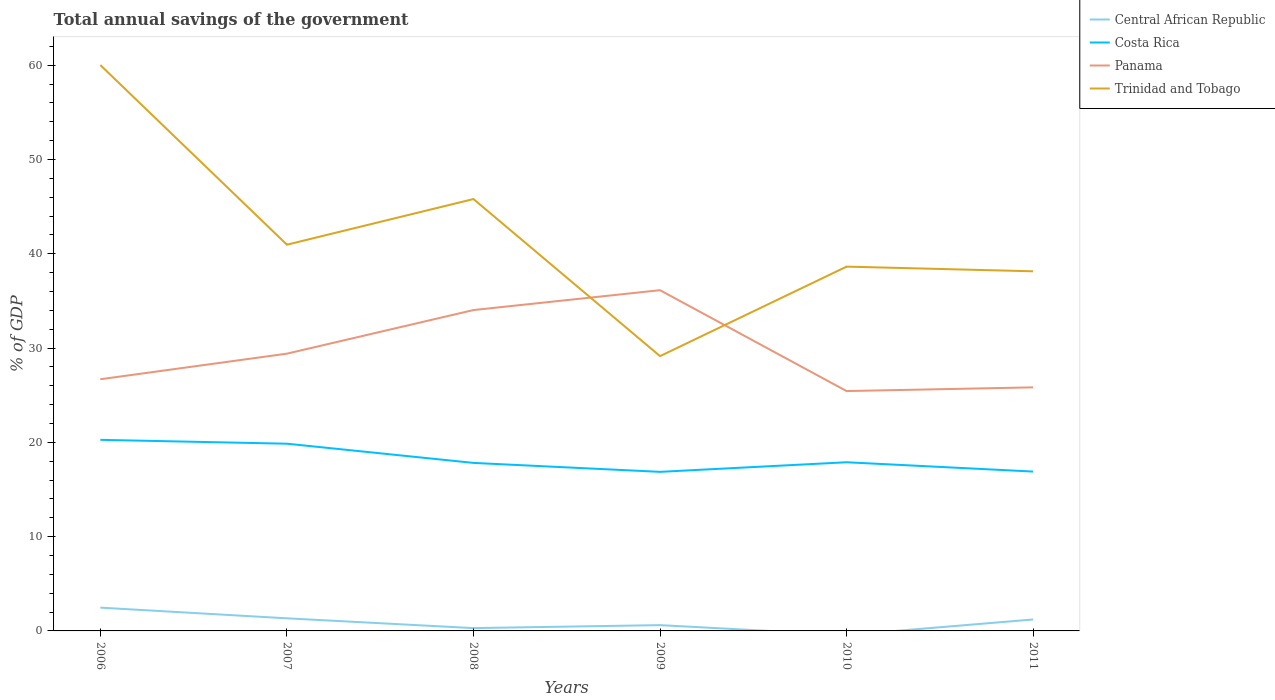How many different coloured lines are there?
Offer a terse response. 4. Is the number of lines equal to the number of legend labels?
Provide a succinct answer. No. What is the total total annual savings of the government in Panama in the graph?
Your answer should be very brief. -6.73. What is the difference between the highest and the second highest total annual savings of the government in Costa Rica?
Keep it short and to the point. 3.4. What is the difference between the highest and the lowest total annual savings of the government in Panama?
Your answer should be compact. 2. How many lines are there?
Make the answer very short. 4. How many years are there in the graph?
Provide a succinct answer. 6. What is the difference between two consecutive major ticks on the Y-axis?
Provide a short and direct response. 10. Where does the legend appear in the graph?
Make the answer very short. Top right. How many legend labels are there?
Ensure brevity in your answer.  4. How are the legend labels stacked?
Your answer should be very brief. Vertical. What is the title of the graph?
Offer a very short reply. Total annual savings of the government. Does "Congo (Democratic)" appear as one of the legend labels in the graph?
Provide a succinct answer. No. What is the label or title of the X-axis?
Offer a very short reply. Years. What is the label or title of the Y-axis?
Offer a very short reply. % of GDP. What is the % of GDP of Central African Republic in 2006?
Offer a very short reply. 2.47. What is the % of GDP of Costa Rica in 2006?
Your answer should be very brief. 20.27. What is the % of GDP in Panama in 2006?
Provide a succinct answer. 26.7. What is the % of GDP in Trinidad and Tobago in 2006?
Your answer should be compact. 60.02. What is the % of GDP of Central African Republic in 2007?
Ensure brevity in your answer.  1.34. What is the % of GDP of Costa Rica in 2007?
Ensure brevity in your answer.  19.86. What is the % of GDP in Panama in 2007?
Ensure brevity in your answer.  29.41. What is the % of GDP of Trinidad and Tobago in 2007?
Keep it short and to the point. 40.97. What is the % of GDP in Central African Republic in 2008?
Your response must be concise. 0.3. What is the % of GDP in Costa Rica in 2008?
Give a very brief answer. 17.82. What is the % of GDP of Panama in 2008?
Give a very brief answer. 34.04. What is the % of GDP of Trinidad and Tobago in 2008?
Give a very brief answer. 45.81. What is the % of GDP of Central African Republic in 2009?
Provide a succinct answer. 0.61. What is the % of GDP in Costa Rica in 2009?
Ensure brevity in your answer.  16.87. What is the % of GDP in Panama in 2009?
Offer a very short reply. 36.14. What is the % of GDP of Trinidad and Tobago in 2009?
Your response must be concise. 29.15. What is the % of GDP of Central African Republic in 2010?
Your response must be concise. 0. What is the % of GDP of Costa Rica in 2010?
Offer a terse response. 17.89. What is the % of GDP in Panama in 2010?
Offer a terse response. 25.44. What is the % of GDP in Trinidad and Tobago in 2010?
Make the answer very short. 38.64. What is the % of GDP of Central African Republic in 2011?
Offer a terse response. 1.21. What is the % of GDP in Costa Rica in 2011?
Your answer should be very brief. 16.9. What is the % of GDP in Panama in 2011?
Provide a short and direct response. 25.84. What is the % of GDP of Trinidad and Tobago in 2011?
Your answer should be compact. 38.15. Across all years, what is the maximum % of GDP in Central African Republic?
Give a very brief answer. 2.47. Across all years, what is the maximum % of GDP of Costa Rica?
Offer a very short reply. 20.27. Across all years, what is the maximum % of GDP in Panama?
Offer a terse response. 36.14. Across all years, what is the maximum % of GDP in Trinidad and Tobago?
Your answer should be very brief. 60.02. Across all years, what is the minimum % of GDP in Central African Republic?
Your answer should be very brief. 0. Across all years, what is the minimum % of GDP in Costa Rica?
Your answer should be very brief. 16.87. Across all years, what is the minimum % of GDP in Panama?
Make the answer very short. 25.44. Across all years, what is the minimum % of GDP of Trinidad and Tobago?
Your answer should be compact. 29.15. What is the total % of GDP in Central African Republic in the graph?
Offer a terse response. 5.93. What is the total % of GDP in Costa Rica in the graph?
Keep it short and to the point. 109.62. What is the total % of GDP in Panama in the graph?
Provide a succinct answer. 177.57. What is the total % of GDP in Trinidad and Tobago in the graph?
Your response must be concise. 252.74. What is the difference between the % of GDP of Central African Republic in 2006 and that in 2007?
Make the answer very short. 1.13. What is the difference between the % of GDP in Costa Rica in 2006 and that in 2007?
Ensure brevity in your answer.  0.41. What is the difference between the % of GDP in Panama in 2006 and that in 2007?
Your answer should be compact. -2.71. What is the difference between the % of GDP of Trinidad and Tobago in 2006 and that in 2007?
Ensure brevity in your answer.  19.05. What is the difference between the % of GDP of Central African Republic in 2006 and that in 2008?
Offer a very short reply. 2.17. What is the difference between the % of GDP in Costa Rica in 2006 and that in 2008?
Provide a short and direct response. 2.45. What is the difference between the % of GDP in Panama in 2006 and that in 2008?
Ensure brevity in your answer.  -7.34. What is the difference between the % of GDP of Trinidad and Tobago in 2006 and that in 2008?
Offer a terse response. 14.21. What is the difference between the % of GDP of Central African Republic in 2006 and that in 2009?
Ensure brevity in your answer.  1.86. What is the difference between the % of GDP of Costa Rica in 2006 and that in 2009?
Your answer should be very brief. 3.4. What is the difference between the % of GDP of Panama in 2006 and that in 2009?
Provide a short and direct response. -9.45. What is the difference between the % of GDP in Trinidad and Tobago in 2006 and that in 2009?
Offer a very short reply. 30.87. What is the difference between the % of GDP in Costa Rica in 2006 and that in 2010?
Provide a short and direct response. 2.38. What is the difference between the % of GDP of Panama in 2006 and that in 2010?
Your response must be concise. 1.25. What is the difference between the % of GDP of Trinidad and Tobago in 2006 and that in 2010?
Your answer should be very brief. 21.38. What is the difference between the % of GDP of Central African Republic in 2006 and that in 2011?
Make the answer very short. 1.26. What is the difference between the % of GDP in Costa Rica in 2006 and that in 2011?
Your answer should be compact. 3.36. What is the difference between the % of GDP in Panama in 2006 and that in 2011?
Your response must be concise. 0.86. What is the difference between the % of GDP of Trinidad and Tobago in 2006 and that in 2011?
Offer a very short reply. 21.88. What is the difference between the % of GDP in Central African Republic in 2007 and that in 2008?
Make the answer very short. 1.04. What is the difference between the % of GDP of Costa Rica in 2007 and that in 2008?
Provide a short and direct response. 2.04. What is the difference between the % of GDP of Panama in 2007 and that in 2008?
Make the answer very short. -4.63. What is the difference between the % of GDP of Trinidad and Tobago in 2007 and that in 2008?
Your answer should be very brief. -4.84. What is the difference between the % of GDP in Central African Republic in 2007 and that in 2009?
Keep it short and to the point. 0.72. What is the difference between the % of GDP of Costa Rica in 2007 and that in 2009?
Provide a short and direct response. 2.99. What is the difference between the % of GDP of Panama in 2007 and that in 2009?
Provide a short and direct response. -6.73. What is the difference between the % of GDP in Trinidad and Tobago in 2007 and that in 2009?
Offer a terse response. 11.82. What is the difference between the % of GDP in Costa Rica in 2007 and that in 2010?
Ensure brevity in your answer.  1.97. What is the difference between the % of GDP of Panama in 2007 and that in 2010?
Your answer should be very brief. 3.97. What is the difference between the % of GDP in Trinidad and Tobago in 2007 and that in 2010?
Provide a short and direct response. 2.33. What is the difference between the % of GDP in Central African Republic in 2007 and that in 2011?
Offer a very short reply. 0.12. What is the difference between the % of GDP in Costa Rica in 2007 and that in 2011?
Make the answer very short. 2.96. What is the difference between the % of GDP of Panama in 2007 and that in 2011?
Keep it short and to the point. 3.57. What is the difference between the % of GDP in Trinidad and Tobago in 2007 and that in 2011?
Offer a very short reply. 2.82. What is the difference between the % of GDP of Central African Republic in 2008 and that in 2009?
Provide a short and direct response. -0.32. What is the difference between the % of GDP of Costa Rica in 2008 and that in 2009?
Ensure brevity in your answer.  0.95. What is the difference between the % of GDP in Panama in 2008 and that in 2009?
Give a very brief answer. -2.11. What is the difference between the % of GDP of Trinidad and Tobago in 2008 and that in 2009?
Keep it short and to the point. 16.66. What is the difference between the % of GDP of Costa Rica in 2008 and that in 2010?
Keep it short and to the point. -0.07. What is the difference between the % of GDP of Panama in 2008 and that in 2010?
Make the answer very short. 8.59. What is the difference between the % of GDP in Trinidad and Tobago in 2008 and that in 2010?
Your response must be concise. 7.17. What is the difference between the % of GDP in Central African Republic in 2008 and that in 2011?
Your response must be concise. -0.92. What is the difference between the % of GDP of Costa Rica in 2008 and that in 2011?
Ensure brevity in your answer.  0.92. What is the difference between the % of GDP of Panama in 2008 and that in 2011?
Your answer should be compact. 8.2. What is the difference between the % of GDP of Trinidad and Tobago in 2008 and that in 2011?
Your answer should be very brief. 7.66. What is the difference between the % of GDP of Costa Rica in 2009 and that in 2010?
Ensure brevity in your answer.  -1.02. What is the difference between the % of GDP of Panama in 2009 and that in 2010?
Give a very brief answer. 10.7. What is the difference between the % of GDP in Trinidad and Tobago in 2009 and that in 2010?
Your answer should be very brief. -9.49. What is the difference between the % of GDP of Central African Republic in 2009 and that in 2011?
Provide a short and direct response. -0.6. What is the difference between the % of GDP of Costa Rica in 2009 and that in 2011?
Make the answer very short. -0.03. What is the difference between the % of GDP in Panama in 2009 and that in 2011?
Ensure brevity in your answer.  10.31. What is the difference between the % of GDP of Trinidad and Tobago in 2009 and that in 2011?
Your answer should be very brief. -9. What is the difference between the % of GDP in Costa Rica in 2010 and that in 2011?
Give a very brief answer. 0.99. What is the difference between the % of GDP in Panama in 2010 and that in 2011?
Ensure brevity in your answer.  -0.39. What is the difference between the % of GDP of Trinidad and Tobago in 2010 and that in 2011?
Offer a very short reply. 0.5. What is the difference between the % of GDP in Central African Republic in 2006 and the % of GDP in Costa Rica in 2007?
Make the answer very short. -17.39. What is the difference between the % of GDP of Central African Republic in 2006 and the % of GDP of Panama in 2007?
Provide a succinct answer. -26.94. What is the difference between the % of GDP of Central African Republic in 2006 and the % of GDP of Trinidad and Tobago in 2007?
Offer a terse response. -38.5. What is the difference between the % of GDP in Costa Rica in 2006 and the % of GDP in Panama in 2007?
Keep it short and to the point. -9.14. What is the difference between the % of GDP in Costa Rica in 2006 and the % of GDP in Trinidad and Tobago in 2007?
Make the answer very short. -20.7. What is the difference between the % of GDP in Panama in 2006 and the % of GDP in Trinidad and Tobago in 2007?
Give a very brief answer. -14.27. What is the difference between the % of GDP in Central African Republic in 2006 and the % of GDP in Costa Rica in 2008?
Ensure brevity in your answer.  -15.35. What is the difference between the % of GDP in Central African Republic in 2006 and the % of GDP in Panama in 2008?
Your answer should be very brief. -31.57. What is the difference between the % of GDP in Central African Republic in 2006 and the % of GDP in Trinidad and Tobago in 2008?
Keep it short and to the point. -43.34. What is the difference between the % of GDP of Costa Rica in 2006 and the % of GDP of Panama in 2008?
Offer a very short reply. -13.77. What is the difference between the % of GDP in Costa Rica in 2006 and the % of GDP in Trinidad and Tobago in 2008?
Make the answer very short. -25.54. What is the difference between the % of GDP of Panama in 2006 and the % of GDP of Trinidad and Tobago in 2008?
Offer a very short reply. -19.11. What is the difference between the % of GDP in Central African Republic in 2006 and the % of GDP in Costa Rica in 2009?
Your answer should be very brief. -14.4. What is the difference between the % of GDP in Central African Republic in 2006 and the % of GDP in Panama in 2009?
Your response must be concise. -33.67. What is the difference between the % of GDP in Central African Republic in 2006 and the % of GDP in Trinidad and Tobago in 2009?
Ensure brevity in your answer.  -26.68. What is the difference between the % of GDP in Costa Rica in 2006 and the % of GDP in Panama in 2009?
Ensure brevity in your answer.  -15.87. What is the difference between the % of GDP in Costa Rica in 2006 and the % of GDP in Trinidad and Tobago in 2009?
Ensure brevity in your answer.  -8.88. What is the difference between the % of GDP of Panama in 2006 and the % of GDP of Trinidad and Tobago in 2009?
Provide a short and direct response. -2.45. What is the difference between the % of GDP in Central African Republic in 2006 and the % of GDP in Costa Rica in 2010?
Provide a succinct answer. -15.42. What is the difference between the % of GDP in Central African Republic in 2006 and the % of GDP in Panama in 2010?
Ensure brevity in your answer.  -22.97. What is the difference between the % of GDP in Central African Republic in 2006 and the % of GDP in Trinidad and Tobago in 2010?
Provide a succinct answer. -36.17. What is the difference between the % of GDP of Costa Rica in 2006 and the % of GDP of Panama in 2010?
Provide a short and direct response. -5.17. What is the difference between the % of GDP of Costa Rica in 2006 and the % of GDP of Trinidad and Tobago in 2010?
Provide a short and direct response. -18.37. What is the difference between the % of GDP of Panama in 2006 and the % of GDP of Trinidad and Tobago in 2010?
Offer a very short reply. -11.95. What is the difference between the % of GDP of Central African Republic in 2006 and the % of GDP of Costa Rica in 2011?
Give a very brief answer. -14.43. What is the difference between the % of GDP in Central African Republic in 2006 and the % of GDP in Panama in 2011?
Offer a terse response. -23.37. What is the difference between the % of GDP of Central African Republic in 2006 and the % of GDP of Trinidad and Tobago in 2011?
Keep it short and to the point. -35.68. What is the difference between the % of GDP of Costa Rica in 2006 and the % of GDP of Panama in 2011?
Give a very brief answer. -5.57. What is the difference between the % of GDP in Costa Rica in 2006 and the % of GDP in Trinidad and Tobago in 2011?
Offer a terse response. -17.88. What is the difference between the % of GDP of Panama in 2006 and the % of GDP of Trinidad and Tobago in 2011?
Give a very brief answer. -11.45. What is the difference between the % of GDP of Central African Republic in 2007 and the % of GDP of Costa Rica in 2008?
Offer a very short reply. -16.49. What is the difference between the % of GDP in Central African Republic in 2007 and the % of GDP in Panama in 2008?
Ensure brevity in your answer.  -32.7. What is the difference between the % of GDP of Central African Republic in 2007 and the % of GDP of Trinidad and Tobago in 2008?
Make the answer very short. -44.47. What is the difference between the % of GDP of Costa Rica in 2007 and the % of GDP of Panama in 2008?
Make the answer very short. -14.18. What is the difference between the % of GDP of Costa Rica in 2007 and the % of GDP of Trinidad and Tobago in 2008?
Your answer should be very brief. -25.95. What is the difference between the % of GDP of Panama in 2007 and the % of GDP of Trinidad and Tobago in 2008?
Give a very brief answer. -16.4. What is the difference between the % of GDP in Central African Republic in 2007 and the % of GDP in Costa Rica in 2009?
Give a very brief answer. -15.54. What is the difference between the % of GDP of Central African Republic in 2007 and the % of GDP of Panama in 2009?
Offer a very short reply. -34.81. What is the difference between the % of GDP of Central African Republic in 2007 and the % of GDP of Trinidad and Tobago in 2009?
Offer a very short reply. -27.81. What is the difference between the % of GDP in Costa Rica in 2007 and the % of GDP in Panama in 2009?
Your answer should be compact. -16.28. What is the difference between the % of GDP in Costa Rica in 2007 and the % of GDP in Trinidad and Tobago in 2009?
Offer a very short reply. -9.29. What is the difference between the % of GDP of Panama in 2007 and the % of GDP of Trinidad and Tobago in 2009?
Your answer should be compact. 0.26. What is the difference between the % of GDP of Central African Republic in 2007 and the % of GDP of Costa Rica in 2010?
Give a very brief answer. -16.56. What is the difference between the % of GDP of Central African Republic in 2007 and the % of GDP of Panama in 2010?
Offer a terse response. -24.11. What is the difference between the % of GDP of Central African Republic in 2007 and the % of GDP of Trinidad and Tobago in 2010?
Offer a very short reply. -37.31. What is the difference between the % of GDP in Costa Rica in 2007 and the % of GDP in Panama in 2010?
Offer a very short reply. -5.58. What is the difference between the % of GDP of Costa Rica in 2007 and the % of GDP of Trinidad and Tobago in 2010?
Offer a very short reply. -18.78. What is the difference between the % of GDP of Panama in 2007 and the % of GDP of Trinidad and Tobago in 2010?
Offer a very short reply. -9.23. What is the difference between the % of GDP in Central African Republic in 2007 and the % of GDP in Costa Rica in 2011?
Offer a terse response. -15.57. What is the difference between the % of GDP in Central African Republic in 2007 and the % of GDP in Panama in 2011?
Your response must be concise. -24.5. What is the difference between the % of GDP in Central African Republic in 2007 and the % of GDP in Trinidad and Tobago in 2011?
Ensure brevity in your answer.  -36.81. What is the difference between the % of GDP of Costa Rica in 2007 and the % of GDP of Panama in 2011?
Your answer should be compact. -5.98. What is the difference between the % of GDP in Costa Rica in 2007 and the % of GDP in Trinidad and Tobago in 2011?
Your answer should be compact. -18.29. What is the difference between the % of GDP of Panama in 2007 and the % of GDP of Trinidad and Tobago in 2011?
Keep it short and to the point. -8.74. What is the difference between the % of GDP of Central African Republic in 2008 and the % of GDP of Costa Rica in 2009?
Keep it short and to the point. -16.58. What is the difference between the % of GDP of Central African Republic in 2008 and the % of GDP of Panama in 2009?
Provide a succinct answer. -35.84. What is the difference between the % of GDP in Central African Republic in 2008 and the % of GDP in Trinidad and Tobago in 2009?
Offer a very short reply. -28.85. What is the difference between the % of GDP of Costa Rica in 2008 and the % of GDP of Panama in 2009?
Your answer should be compact. -18.32. What is the difference between the % of GDP in Costa Rica in 2008 and the % of GDP in Trinidad and Tobago in 2009?
Give a very brief answer. -11.33. What is the difference between the % of GDP of Panama in 2008 and the % of GDP of Trinidad and Tobago in 2009?
Provide a short and direct response. 4.89. What is the difference between the % of GDP in Central African Republic in 2008 and the % of GDP in Costa Rica in 2010?
Keep it short and to the point. -17.59. What is the difference between the % of GDP in Central African Republic in 2008 and the % of GDP in Panama in 2010?
Make the answer very short. -25.14. What is the difference between the % of GDP of Central African Republic in 2008 and the % of GDP of Trinidad and Tobago in 2010?
Your answer should be very brief. -38.34. What is the difference between the % of GDP of Costa Rica in 2008 and the % of GDP of Panama in 2010?
Provide a short and direct response. -7.62. What is the difference between the % of GDP in Costa Rica in 2008 and the % of GDP in Trinidad and Tobago in 2010?
Provide a short and direct response. -20.82. What is the difference between the % of GDP in Panama in 2008 and the % of GDP in Trinidad and Tobago in 2010?
Offer a very short reply. -4.61. What is the difference between the % of GDP in Central African Republic in 2008 and the % of GDP in Costa Rica in 2011?
Provide a succinct answer. -16.61. What is the difference between the % of GDP of Central African Republic in 2008 and the % of GDP of Panama in 2011?
Give a very brief answer. -25.54. What is the difference between the % of GDP in Central African Republic in 2008 and the % of GDP in Trinidad and Tobago in 2011?
Provide a short and direct response. -37.85. What is the difference between the % of GDP of Costa Rica in 2008 and the % of GDP of Panama in 2011?
Make the answer very short. -8.01. What is the difference between the % of GDP of Costa Rica in 2008 and the % of GDP of Trinidad and Tobago in 2011?
Provide a succinct answer. -20.32. What is the difference between the % of GDP in Panama in 2008 and the % of GDP in Trinidad and Tobago in 2011?
Ensure brevity in your answer.  -4.11. What is the difference between the % of GDP of Central African Republic in 2009 and the % of GDP of Costa Rica in 2010?
Ensure brevity in your answer.  -17.28. What is the difference between the % of GDP in Central African Republic in 2009 and the % of GDP in Panama in 2010?
Keep it short and to the point. -24.83. What is the difference between the % of GDP in Central African Republic in 2009 and the % of GDP in Trinidad and Tobago in 2010?
Provide a short and direct response. -38.03. What is the difference between the % of GDP of Costa Rica in 2009 and the % of GDP of Panama in 2010?
Offer a terse response. -8.57. What is the difference between the % of GDP in Costa Rica in 2009 and the % of GDP in Trinidad and Tobago in 2010?
Keep it short and to the point. -21.77. What is the difference between the % of GDP in Panama in 2009 and the % of GDP in Trinidad and Tobago in 2010?
Your response must be concise. -2.5. What is the difference between the % of GDP of Central African Republic in 2009 and the % of GDP of Costa Rica in 2011?
Your answer should be compact. -16.29. What is the difference between the % of GDP of Central African Republic in 2009 and the % of GDP of Panama in 2011?
Provide a succinct answer. -25.22. What is the difference between the % of GDP in Central African Republic in 2009 and the % of GDP in Trinidad and Tobago in 2011?
Your response must be concise. -37.53. What is the difference between the % of GDP of Costa Rica in 2009 and the % of GDP of Panama in 2011?
Ensure brevity in your answer.  -8.96. What is the difference between the % of GDP in Costa Rica in 2009 and the % of GDP in Trinidad and Tobago in 2011?
Your answer should be very brief. -21.27. What is the difference between the % of GDP of Panama in 2009 and the % of GDP of Trinidad and Tobago in 2011?
Your answer should be compact. -2. What is the difference between the % of GDP of Costa Rica in 2010 and the % of GDP of Panama in 2011?
Your answer should be very brief. -7.94. What is the difference between the % of GDP of Costa Rica in 2010 and the % of GDP of Trinidad and Tobago in 2011?
Provide a succinct answer. -20.26. What is the difference between the % of GDP of Panama in 2010 and the % of GDP of Trinidad and Tobago in 2011?
Ensure brevity in your answer.  -12.7. What is the average % of GDP in Central African Republic per year?
Offer a terse response. 0.99. What is the average % of GDP of Costa Rica per year?
Give a very brief answer. 18.27. What is the average % of GDP of Panama per year?
Give a very brief answer. 29.59. What is the average % of GDP in Trinidad and Tobago per year?
Your answer should be very brief. 42.12. In the year 2006, what is the difference between the % of GDP of Central African Republic and % of GDP of Costa Rica?
Your response must be concise. -17.8. In the year 2006, what is the difference between the % of GDP in Central African Republic and % of GDP in Panama?
Your answer should be very brief. -24.23. In the year 2006, what is the difference between the % of GDP of Central African Republic and % of GDP of Trinidad and Tobago?
Provide a succinct answer. -57.55. In the year 2006, what is the difference between the % of GDP in Costa Rica and % of GDP in Panama?
Offer a very short reply. -6.43. In the year 2006, what is the difference between the % of GDP in Costa Rica and % of GDP in Trinidad and Tobago?
Offer a very short reply. -39.75. In the year 2006, what is the difference between the % of GDP of Panama and % of GDP of Trinidad and Tobago?
Your answer should be very brief. -33.33. In the year 2007, what is the difference between the % of GDP of Central African Republic and % of GDP of Costa Rica?
Ensure brevity in your answer.  -18.52. In the year 2007, what is the difference between the % of GDP of Central African Republic and % of GDP of Panama?
Your answer should be compact. -28.07. In the year 2007, what is the difference between the % of GDP in Central African Republic and % of GDP in Trinidad and Tobago?
Offer a terse response. -39.63. In the year 2007, what is the difference between the % of GDP in Costa Rica and % of GDP in Panama?
Your response must be concise. -9.55. In the year 2007, what is the difference between the % of GDP in Costa Rica and % of GDP in Trinidad and Tobago?
Give a very brief answer. -21.11. In the year 2007, what is the difference between the % of GDP in Panama and % of GDP in Trinidad and Tobago?
Your response must be concise. -11.56. In the year 2008, what is the difference between the % of GDP of Central African Republic and % of GDP of Costa Rica?
Keep it short and to the point. -17.52. In the year 2008, what is the difference between the % of GDP in Central African Republic and % of GDP in Panama?
Offer a terse response. -33.74. In the year 2008, what is the difference between the % of GDP in Central African Republic and % of GDP in Trinidad and Tobago?
Your answer should be very brief. -45.51. In the year 2008, what is the difference between the % of GDP of Costa Rica and % of GDP of Panama?
Ensure brevity in your answer.  -16.21. In the year 2008, what is the difference between the % of GDP of Costa Rica and % of GDP of Trinidad and Tobago?
Offer a very short reply. -27.99. In the year 2008, what is the difference between the % of GDP of Panama and % of GDP of Trinidad and Tobago?
Your answer should be very brief. -11.77. In the year 2009, what is the difference between the % of GDP in Central African Republic and % of GDP in Costa Rica?
Provide a succinct answer. -16.26. In the year 2009, what is the difference between the % of GDP of Central African Republic and % of GDP of Panama?
Offer a very short reply. -35.53. In the year 2009, what is the difference between the % of GDP of Central African Republic and % of GDP of Trinidad and Tobago?
Provide a succinct answer. -28.53. In the year 2009, what is the difference between the % of GDP in Costa Rica and % of GDP in Panama?
Give a very brief answer. -19.27. In the year 2009, what is the difference between the % of GDP of Costa Rica and % of GDP of Trinidad and Tobago?
Ensure brevity in your answer.  -12.27. In the year 2009, what is the difference between the % of GDP of Panama and % of GDP of Trinidad and Tobago?
Keep it short and to the point. 6.99. In the year 2010, what is the difference between the % of GDP of Costa Rica and % of GDP of Panama?
Your answer should be very brief. -7.55. In the year 2010, what is the difference between the % of GDP in Costa Rica and % of GDP in Trinidad and Tobago?
Provide a succinct answer. -20.75. In the year 2010, what is the difference between the % of GDP of Panama and % of GDP of Trinidad and Tobago?
Make the answer very short. -13.2. In the year 2011, what is the difference between the % of GDP of Central African Republic and % of GDP of Costa Rica?
Ensure brevity in your answer.  -15.69. In the year 2011, what is the difference between the % of GDP of Central African Republic and % of GDP of Panama?
Provide a succinct answer. -24.62. In the year 2011, what is the difference between the % of GDP in Central African Republic and % of GDP in Trinidad and Tobago?
Your answer should be very brief. -36.93. In the year 2011, what is the difference between the % of GDP in Costa Rica and % of GDP in Panama?
Offer a terse response. -8.93. In the year 2011, what is the difference between the % of GDP of Costa Rica and % of GDP of Trinidad and Tobago?
Ensure brevity in your answer.  -21.24. In the year 2011, what is the difference between the % of GDP of Panama and % of GDP of Trinidad and Tobago?
Your answer should be compact. -12.31. What is the ratio of the % of GDP in Central African Republic in 2006 to that in 2007?
Offer a terse response. 1.85. What is the ratio of the % of GDP in Costa Rica in 2006 to that in 2007?
Your answer should be compact. 1.02. What is the ratio of the % of GDP of Panama in 2006 to that in 2007?
Your answer should be compact. 0.91. What is the ratio of the % of GDP of Trinidad and Tobago in 2006 to that in 2007?
Provide a succinct answer. 1.47. What is the ratio of the % of GDP in Central African Republic in 2006 to that in 2008?
Your answer should be compact. 8.28. What is the ratio of the % of GDP in Costa Rica in 2006 to that in 2008?
Offer a very short reply. 1.14. What is the ratio of the % of GDP of Panama in 2006 to that in 2008?
Keep it short and to the point. 0.78. What is the ratio of the % of GDP in Trinidad and Tobago in 2006 to that in 2008?
Offer a very short reply. 1.31. What is the ratio of the % of GDP in Central African Republic in 2006 to that in 2009?
Ensure brevity in your answer.  4.02. What is the ratio of the % of GDP in Costa Rica in 2006 to that in 2009?
Your response must be concise. 1.2. What is the ratio of the % of GDP in Panama in 2006 to that in 2009?
Provide a succinct answer. 0.74. What is the ratio of the % of GDP of Trinidad and Tobago in 2006 to that in 2009?
Make the answer very short. 2.06. What is the ratio of the % of GDP of Costa Rica in 2006 to that in 2010?
Offer a terse response. 1.13. What is the ratio of the % of GDP in Panama in 2006 to that in 2010?
Offer a very short reply. 1.05. What is the ratio of the % of GDP of Trinidad and Tobago in 2006 to that in 2010?
Your answer should be compact. 1.55. What is the ratio of the % of GDP of Central African Republic in 2006 to that in 2011?
Offer a terse response. 2.03. What is the ratio of the % of GDP of Costa Rica in 2006 to that in 2011?
Your answer should be very brief. 1.2. What is the ratio of the % of GDP of Panama in 2006 to that in 2011?
Keep it short and to the point. 1.03. What is the ratio of the % of GDP in Trinidad and Tobago in 2006 to that in 2011?
Give a very brief answer. 1.57. What is the ratio of the % of GDP of Central African Republic in 2007 to that in 2008?
Offer a very short reply. 4.48. What is the ratio of the % of GDP in Costa Rica in 2007 to that in 2008?
Your response must be concise. 1.11. What is the ratio of the % of GDP of Panama in 2007 to that in 2008?
Offer a terse response. 0.86. What is the ratio of the % of GDP in Trinidad and Tobago in 2007 to that in 2008?
Offer a very short reply. 0.89. What is the ratio of the % of GDP in Central African Republic in 2007 to that in 2009?
Provide a short and direct response. 2.18. What is the ratio of the % of GDP in Costa Rica in 2007 to that in 2009?
Offer a terse response. 1.18. What is the ratio of the % of GDP of Panama in 2007 to that in 2009?
Offer a very short reply. 0.81. What is the ratio of the % of GDP of Trinidad and Tobago in 2007 to that in 2009?
Provide a short and direct response. 1.41. What is the ratio of the % of GDP of Costa Rica in 2007 to that in 2010?
Make the answer very short. 1.11. What is the ratio of the % of GDP in Panama in 2007 to that in 2010?
Ensure brevity in your answer.  1.16. What is the ratio of the % of GDP in Trinidad and Tobago in 2007 to that in 2010?
Provide a succinct answer. 1.06. What is the ratio of the % of GDP of Central African Republic in 2007 to that in 2011?
Give a very brief answer. 1.1. What is the ratio of the % of GDP in Costa Rica in 2007 to that in 2011?
Give a very brief answer. 1.17. What is the ratio of the % of GDP in Panama in 2007 to that in 2011?
Give a very brief answer. 1.14. What is the ratio of the % of GDP in Trinidad and Tobago in 2007 to that in 2011?
Offer a very short reply. 1.07. What is the ratio of the % of GDP of Central African Republic in 2008 to that in 2009?
Give a very brief answer. 0.49. What is the ratio of the % of GDP in Costa Rica in 2008 to that in 2009?
Keep it short and to the point. 1.06. What is the ratio of the % of GDP of Panama in 2008 to that in 2009?
Your response must be concise. 0.94. What is the ratio of the % of GDP in Trinidad and Tobago in 2008 to that in 2009?
Your answer should be compact. 1.57. What is the ratio of the % of GDP in Costa Rica in 2008 to that in 2010?
Offer a terse response. 1. What is the ratio of the % of GDP in Panama in 2008 to that in 2010?
Make the answer very short. 1.34. What is the ratio of the % of GDP of Trinidad and Tobago in 2008 to that in 2010?
Your answer should be very brief. 1.19. What is the ratio of the % of GDP in Central African Republic in 2008 to that in 2011?
Give a very brief answer. 0.25. What is the ratio of the % of GDP in Costa Rica in 2008 to that in 2011?
Provide a succinct answer. 1.05. What is the ratio of the % of GDP of Panama in 2008 to that in 2011?
Keep it short and to the point. 1.32. What is the ratio of the % of GDP in Trinidad and Tobago in 2008 to that in 2011?
Your answer should be very brief. 1.2. What is the ratio of the % of GDP in Costa Rica in 2009 to that in 2010?
Provide a succinct answer. 0.94. What is the ratio of the % of GDP in Panama in 2009 to that in 2010?
Ensure brevity in your answer.  1.42. What is the ratio of the % of GDP in Trinidad and Tobago in 2009 to that in 2010?
Offer a very short reply. 0.75. What is the ratio of the % of GDP of Central African Republic in 2009 to that in 2011?
Offer a terse response. 0.51. What is the ratio of the % of GDP in Panama in 2009 to that in 2011?
Keep it short and to the point. 1.4. What is the ratio of the % of GDP of Trinidad and Tobago in 2009 to that in 2011?
Your response must be concise. 0.76. What is the ratio of the % of GDP in Costa Rica in 2010 to that in 2011?
Your response must be concise. 1.06. What is the ratio of the % of GDP in Panama in 2010 to that in 2011?
Make the answer very short. 0.98. What is the ratio of the % of GDP of Trinidad and Tobago in 2010 to that in 2011?
Provide a short and direct response. 1.01. What is the difference between the highest and the second highest % of GDP in Central African Republic?
Your answer should be compact. 1.13. What is the difference between the highest and the second highest % of GDP in Costa Rica?
Ensure brevity in your answer.  0.41. What is the difference between the highest and the second highest % of GDP of Panama?
Your answer should be very brief. 2.11. What is the difference between the highest and the second highest % of GDP of Trinidad and Tobago?
Your answer should be very brief. 14.21. What is the difference between the highest and the lowest % of GDP in Central African Republic?
Keep it short and to the point. 2.47. What is the difference between the highest and the lowest % of GDP of Costa Rica?
Give a very brief answer. 3.4. What is the difference between the highest and the lowest % of GDP in Panama?
Provide a succinct answer. 10.7. What is the difference between the highest and the lowest % of GDP of Trinidad and Tobago?
Offer a terse response. 30.87. 